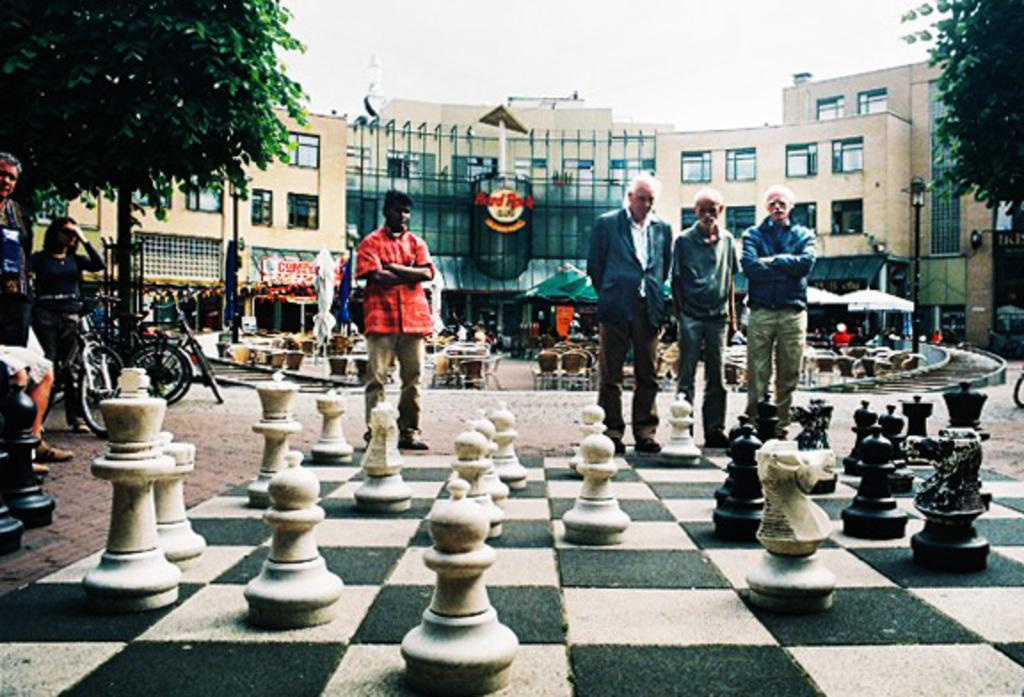<image>
Present a compact description of the photo's key features. People playing big chess in front of the Hard Rock. 